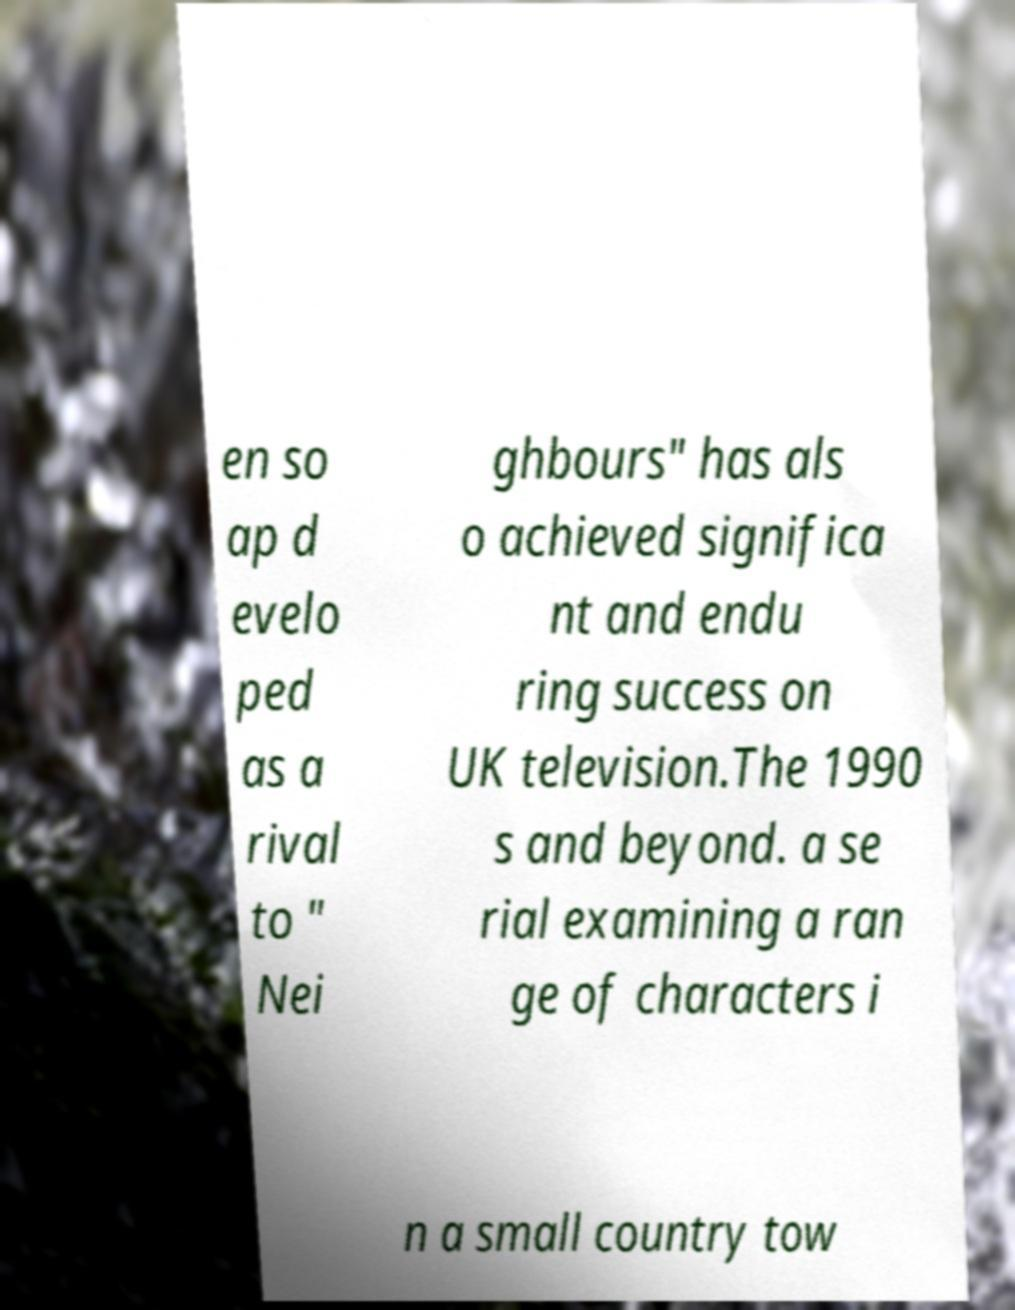There's text embedded in this image that I need extracted. Can you transcribe it verbatim? en so ap d evelo ped as a rival to " Nei ghbours" has als o achieved significa nt and endu ring success on UK television.The 1990 s and beyond. a se rial examining a ran ge of characters i n a small country tow 